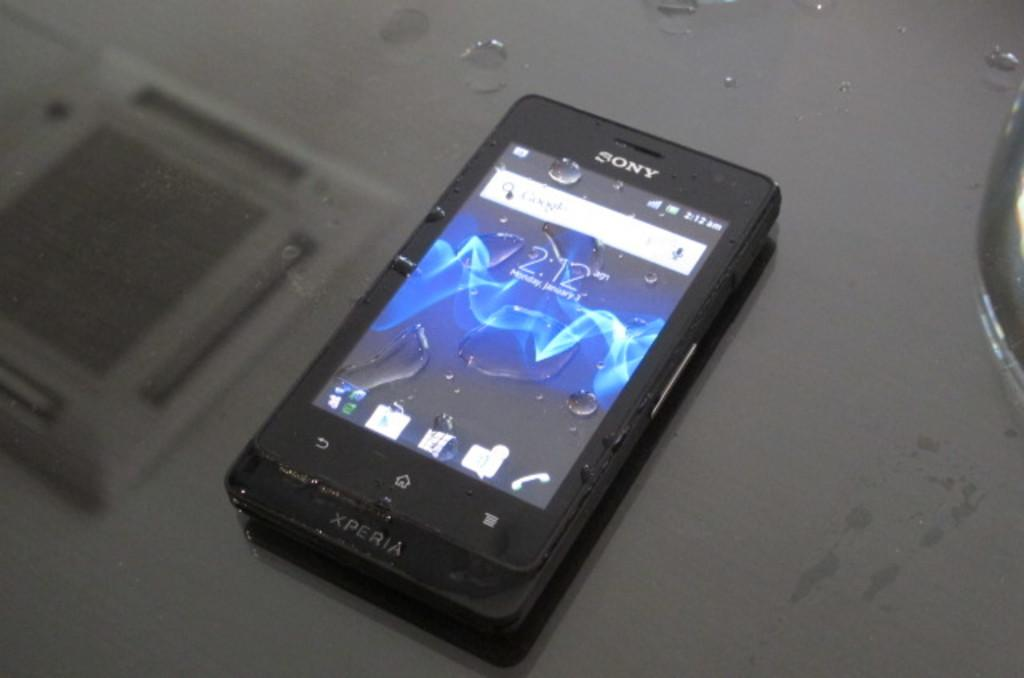<image>
Share a concise interpretation of the image provided. a Sony Xperia phone with water drops and lit up display 